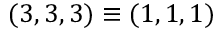Convert formula to latex. <formula><loc_0><loc_0><loc_500><loc_500>( 3 , 3 , 3 ) \equiv ( 1 , 1 , 1 )</formula> 